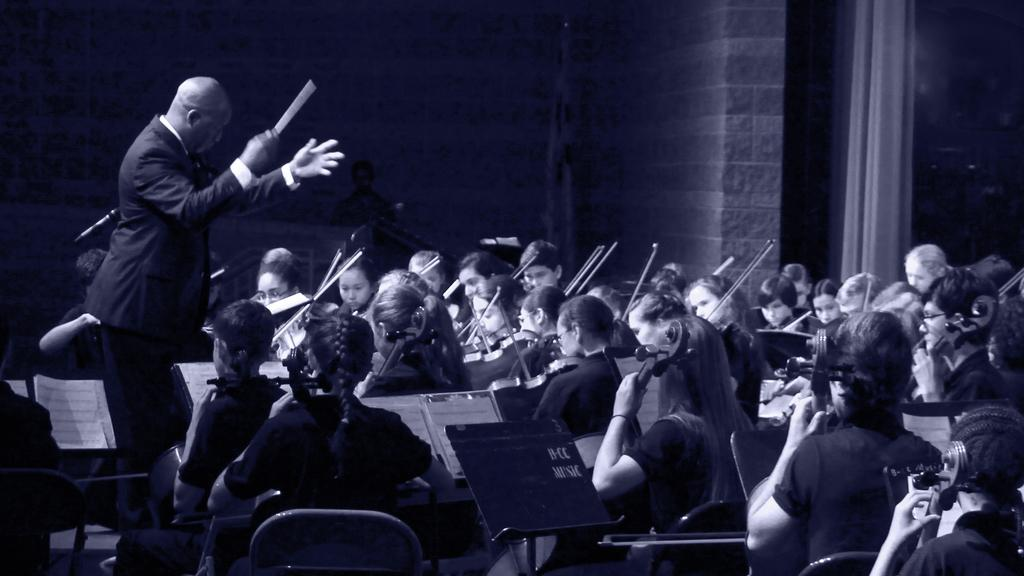What are the people in the image doing? Some of the people are sitting on chairs, and some are playing musical instruments. Can you describe the person holding a stick? Yes, there is a person holding a stick in the image. How does the boy's growth rate compare to the other people in the image? There is no boy mentioned in the image, and therefore no growth rate can be compared. 